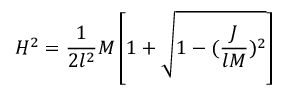Convert formula to latex. <formula><loc_0><loc_0><loc_500><loc_500>H ^ { 2 } = \frac { 1 } { 2 l ^ { 2 } } M \left [ 1 + \sqrt { 1 - ( \frac { J } { l M } ) ^ { 2 } } \right ]</formula> 